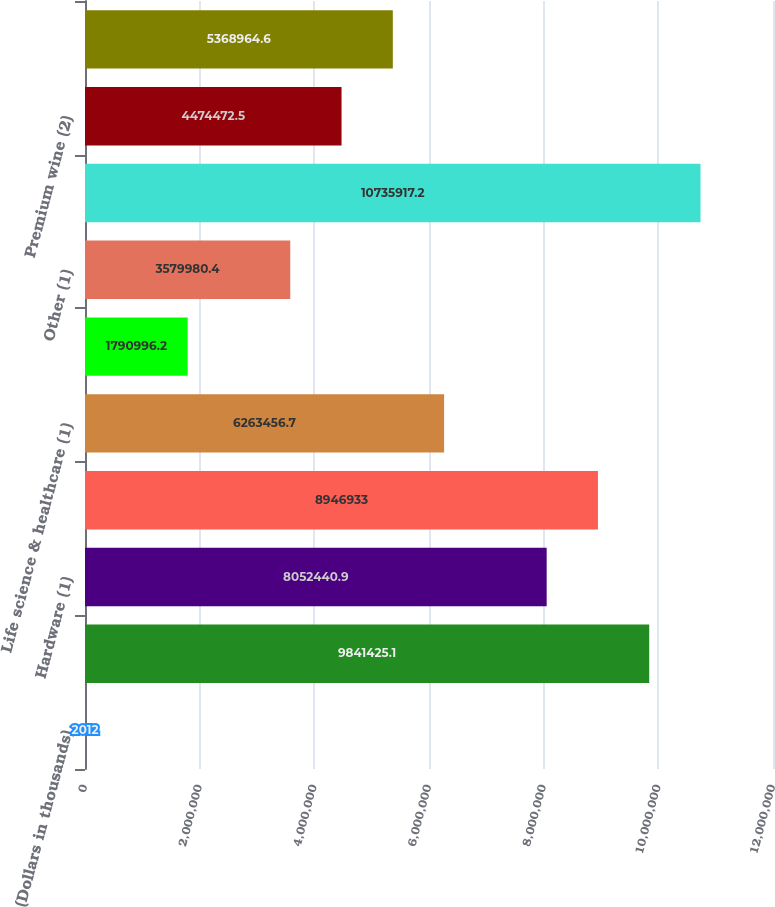Convert chart to OTSL. <chart><loc_0><loc_0><loc_500><loc_500><bar_chart><fcel>(Dollars in thousands)<fcel>Software and internet (1)<fcel>Hardware (1)<fcel>Private equity/venture capital<fcel>Life science & healthcare (1)<fcel>Premium wine<fcel>Other (1)<fcel>Total commercial loans<fcel>Premium wine (2)<fcel>Consumer loans (3)<nl><fcel>2012<fcel>9.84143e+06<fcel>8.05244e+06<fcel>8.94693e+06<fcel>6.26346e+06<fcel>1.791e+06<fcel>3.57998e+06<fcel>1.07359e+07<fcel>4.47447e+06<fcel>5.36896e+06<nl></chart> 